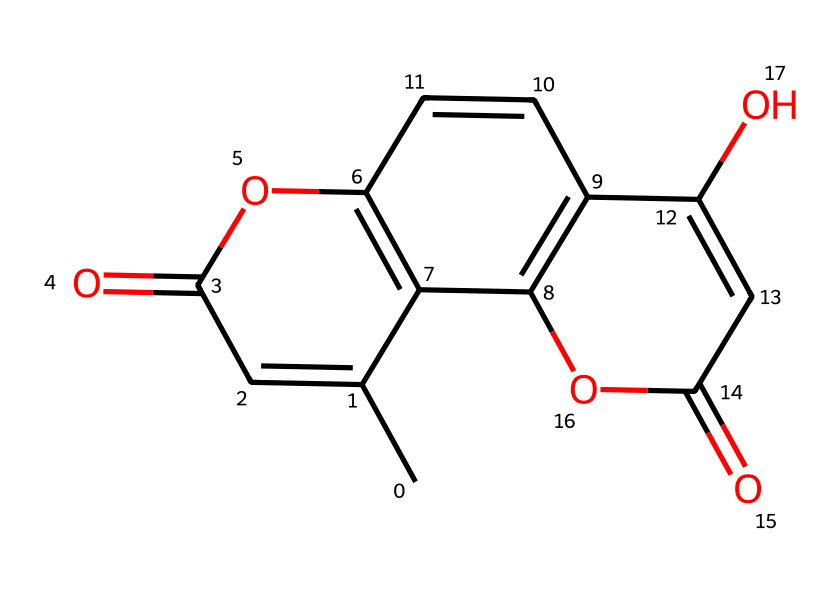How many rings are present in this chemical structure? By examining the SMILES representation, we can identify that there are multiple cyclic parts. Notably, the structure contains three interconnected rings, as indicated by the use of 'C' and the indices such as 'C1', 'C2', and 'C3', which denote the starting and ending points of these rings.
Answer: three What is the primary functional group in this structure? Looking closely at the chemical, we identify the presence of carbonyl (C=O) groups and an ester (–O–C=O) group. The presence of two carbonyls suggests that the primary functional groups are keto and carboxylic acid. However, the most prominent functional group based on the structure is the ester.
Answer: ester Does this compound contain any hydroxy groups? Analyzing the structure, we notice that there are two oxygen atoms indicated by -OH in the form of hydroxyl groups, which are shown in the structure as -O- connected to carbon atoms. Therefore, we confirm that this compound does indeed contain hydroxy groups.
Answer: yes What type of compound is represented by this SMILES? The overall structure features multiple fused aromatic rings along with various functional groups, such as hydroxyl and carbonyl groups. This indicates that the compound is a type of polyphenolic compound, which is commonly found in botanical drugs.
Answer: polyphenolic How many oxygen atoms are present in this chemical? To assess the number of oxygen atoms, we can review the components of the structure closely. The recognizable functional groups (carbonyl and hydroxyl) contribute oxygen atoms. Upon careful examination, we tally the total and find there are four oxygen atoms in the structure.
Answer: four 